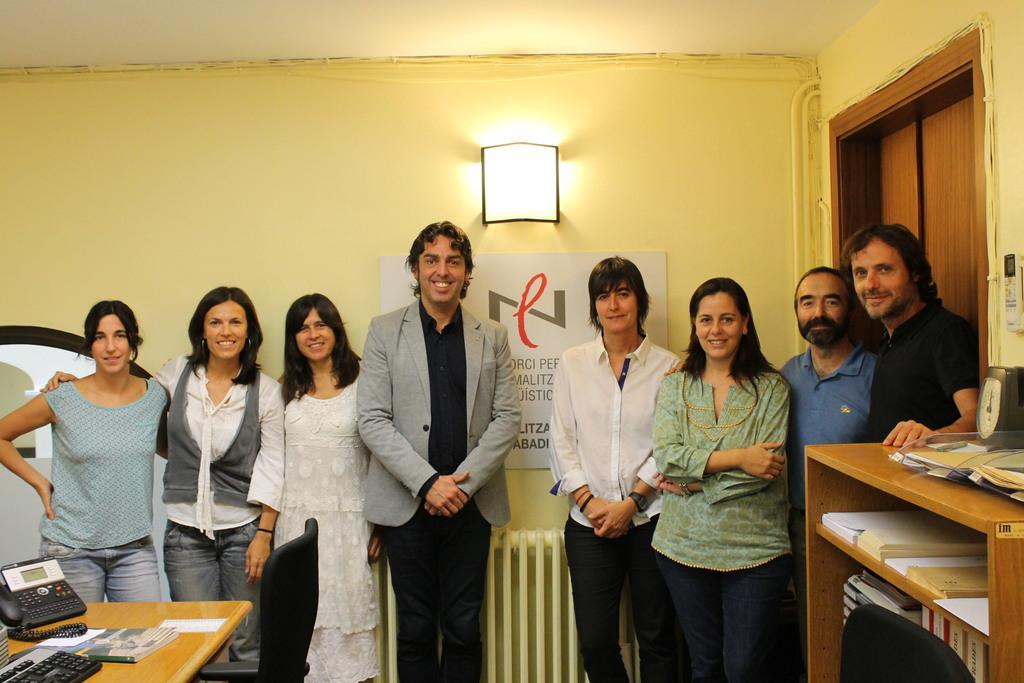Could you give a brief overview of what you see in this image? As we can see in the image there are group of people standing. Behind them there is a yellow color wall. In the front there is table. On table there is a book, phone, keyboard and on the right side there is a shelf with books and clock. 